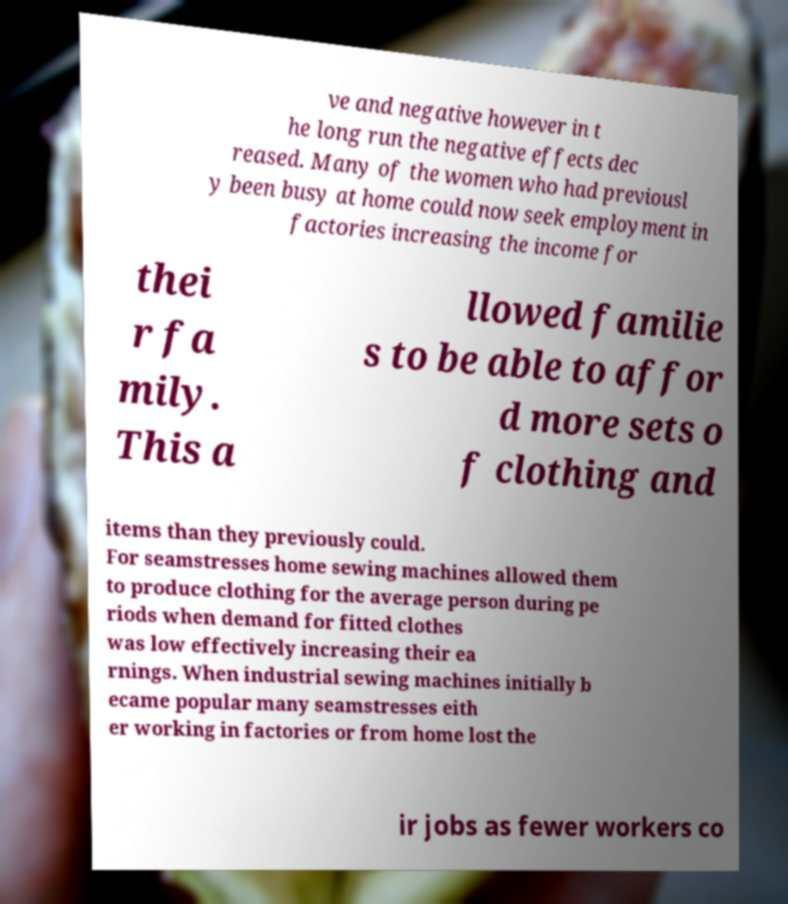For documentation purposes, I need the text within this image transcribed. Could you provide that? ve and negative however in t he long run the negative effects dec reased. Many of the women who had previousl y been busy at home could now seek employment in factories increasing the income for thei r fa mily. This a llowed familie s to be able to affor d more sets o f clothing and items than they previously could. For seamstresses home sewing machines allowed them to produce clothing for the average person during pe riods when demand for fitted clothes was low effectively increasing their ea rnings. When industrial sewing machines initially b ecame popular many seamstresses eith er working in factories or from home lost the ir jobs as fewer workers co 